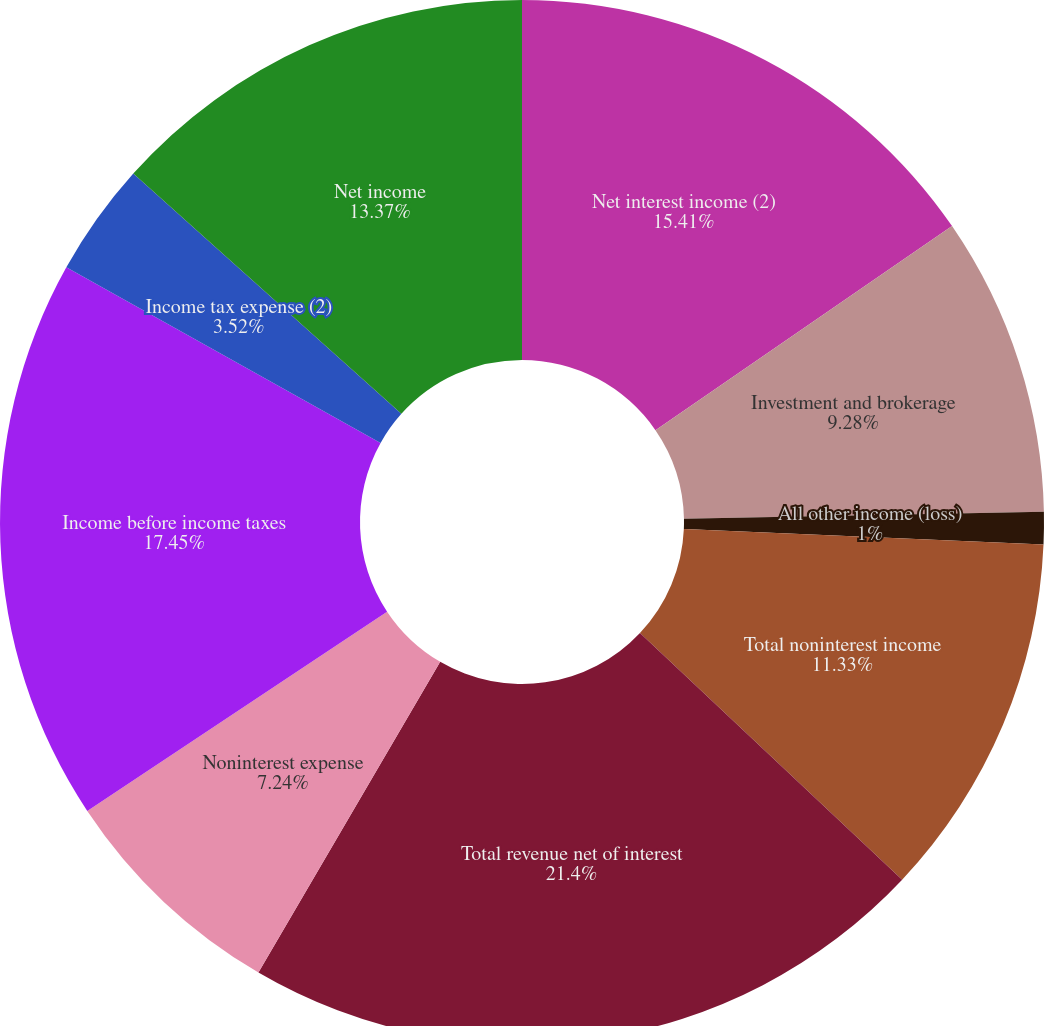<chart> <loc_0><loc_0><loc_500><loc_500><pie_chart><fcel>Net interest income (2)<fcel>Investment and brokerage<fcel>All other income (loss)<fcel>Total noninterest income<fcel>Total revenue net of interest<fcel>Noninterest expense<fcel>Income before income taxes<fcel>Income tax expense (2)<fcel>Net income<nl><fcel>15.41%<fcel>9.28%<fcel>1.0%<fcel>11.33%<fcel>21.41%<fcel>7.24%<fcel>17.45%<fcel>3.52%<fcel>13.37%<nl></chart> 